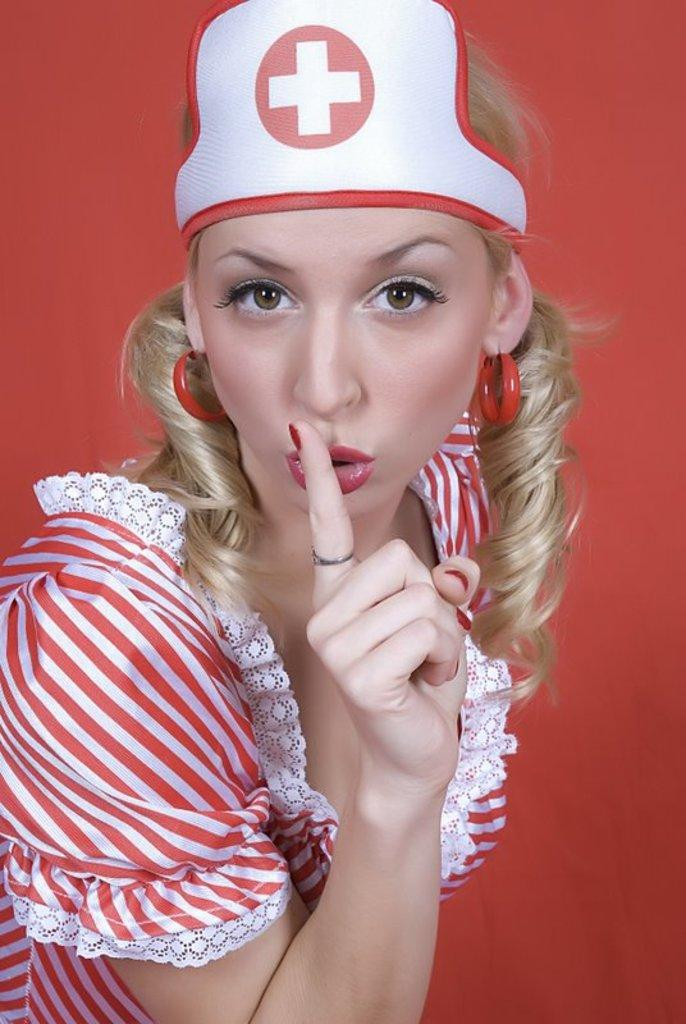Who is the main subject in the image? There is a woman in the image. What is the woman wearing? The woman is wearing a red dress, a cap, and red earrings. What color is the wall in the background of the image? The wall in the background of the image has a red color. What type of judgment is the woman making in the image? There is no indication in the image that the woman is making any judgment or decision. 